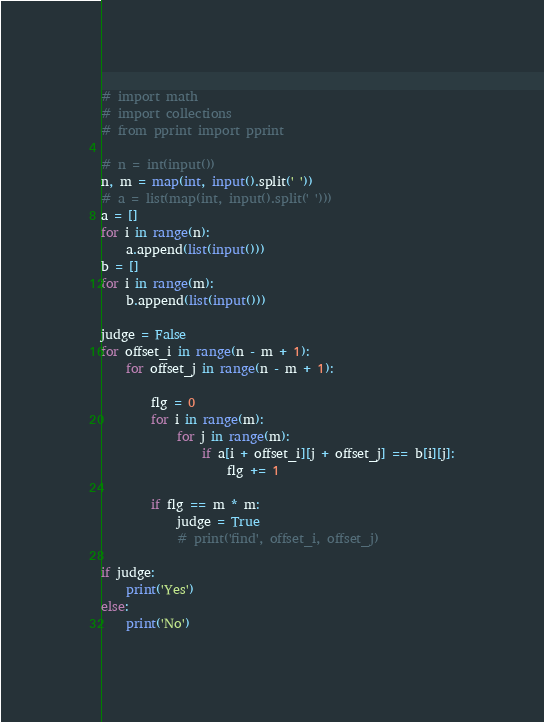Convert code to text. <code><loc_0><loc_0><loc_500><loc_500><_Python_># import math
# import collections
# from pprint import pprint

# n = int(input())
n, m = map(int, input().split(' '))
# a = list(map(int, input().split(' ')))
a = []
for i in range(n):
    a.append(list(input()))
b = []
for i in range(m):
    b.append(list(input()))

judge = False
for offset_i in range(n - m + 1):
    for offset_j in range(n - m + 1):

        flg = 0
        for i in range(m):
            for j in range(m):
                if a[i + offset_i][j + offset_j] == b[i][j]:
                    flg += 1

        if flg == m * m:
            judge = True
            # print('find', offset_i, offset_j)

if judge:
    print('Yes')
else:
    print('No')
</code> 